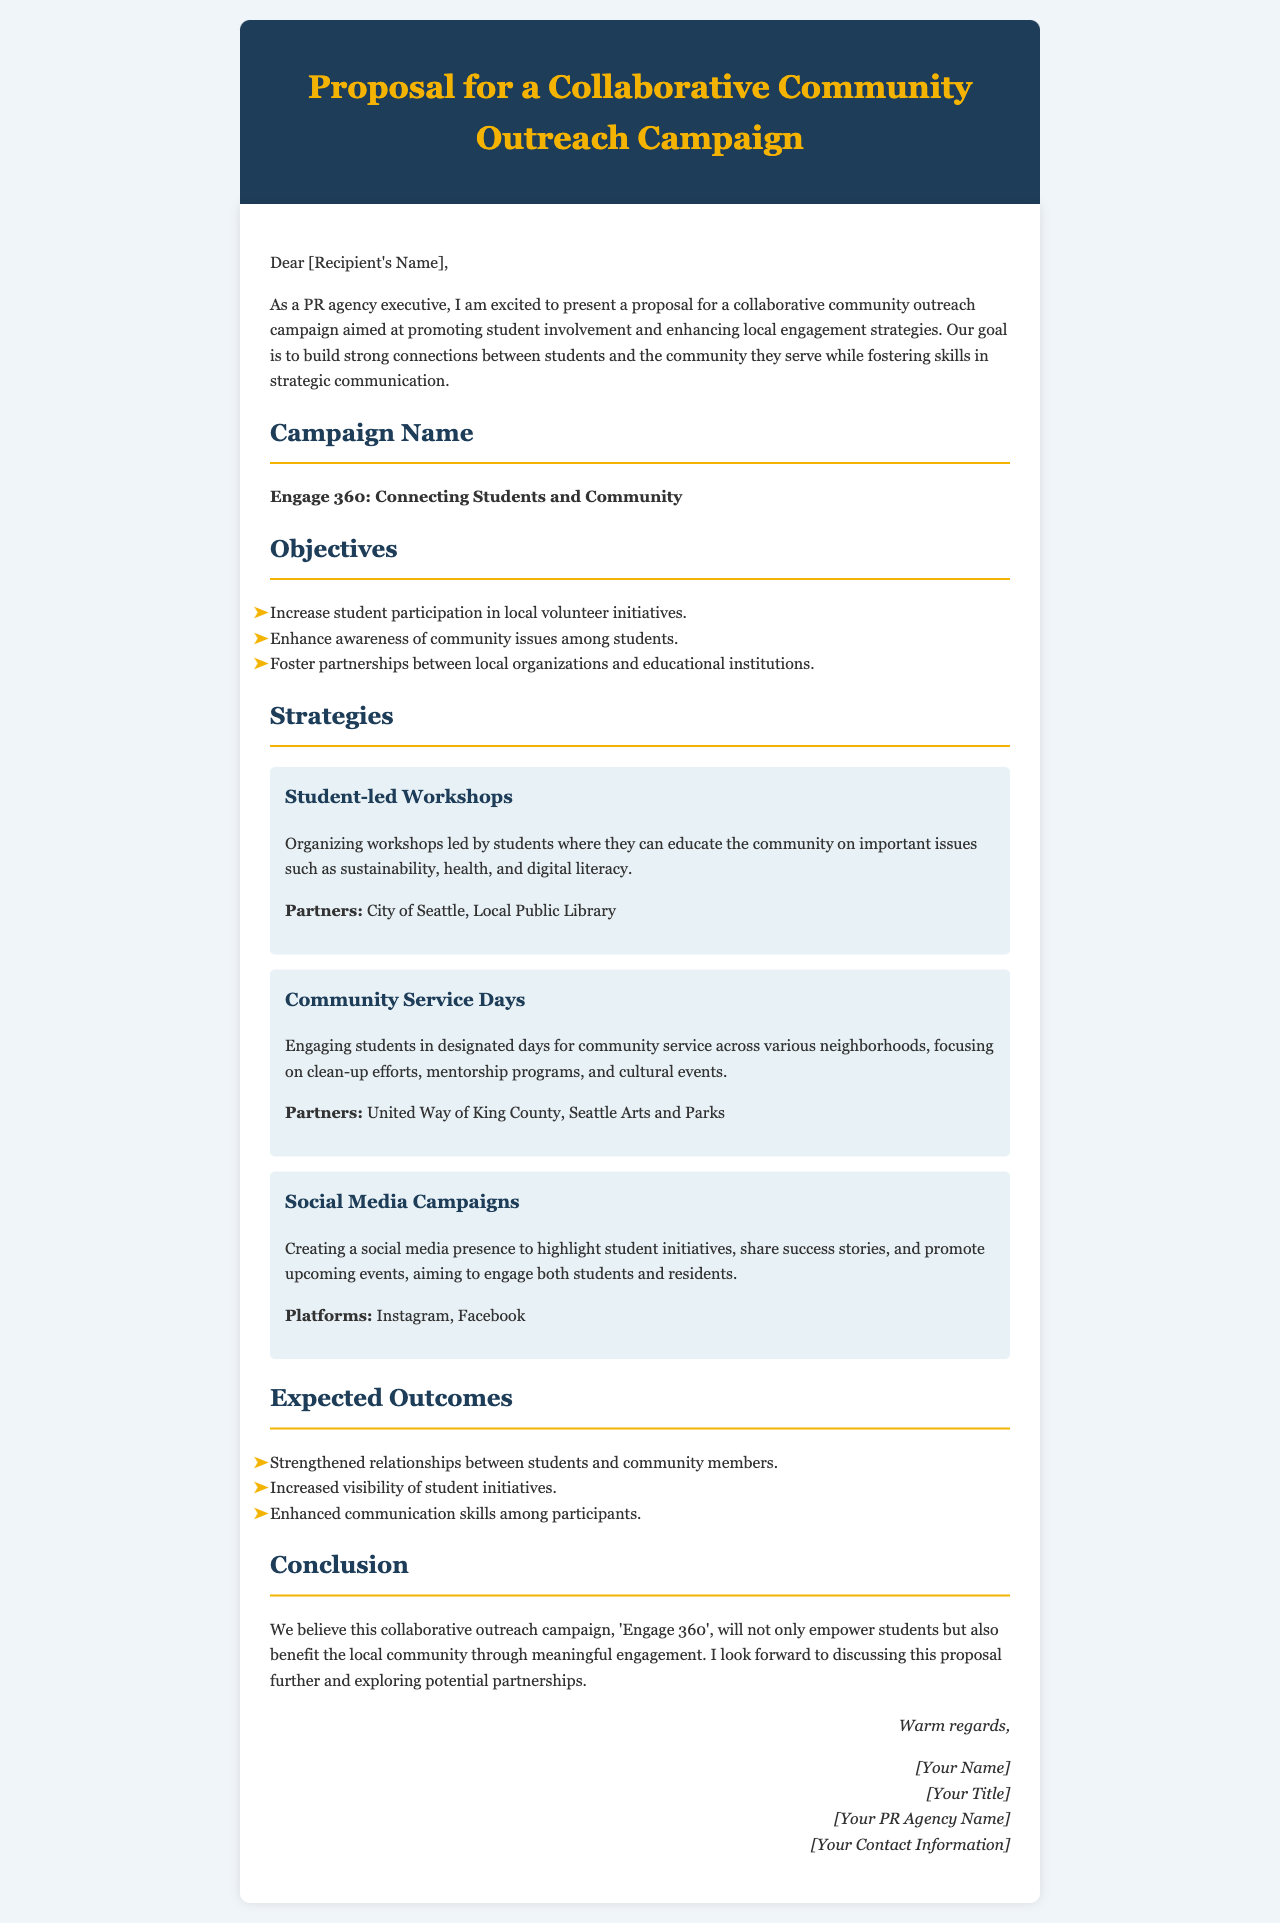What is the name of the campaign? The name of the campaign is explicitly stated in the document under "Campaign Name."
Answer: Engage 360: Connecting Students and Community What are the first two objectives of the campaign? The first two objectives are listed in the "Objectives" section of the document.
Answer: Increase student participation in local volunteer initiatives, Enhance awareness of community issues among students Who are the partners for the Student-led Workshops? The partners for the Student-led Workshops can be found in the details provided under that strategy.
Answer: City of Seattle, Local Public Library What is one expected outcome of the campaign? Expected outcomes are summarized in the "Expected Outcomes" section, requiring an understanding of the document's content to answer.
Answer: Strengthened relationships between students and community members What type of content will be highlighted in the Social Media Campaigns? The type of content is described within the "Social Media Campaigns" strategy section.
Answer: Student initiatives, success stories, and upcoming events How many strategies are mentioned in the proposal? The strategies are enumerated in the "Strategies" section by counting each distinct strategy listed.
Answer: Three 